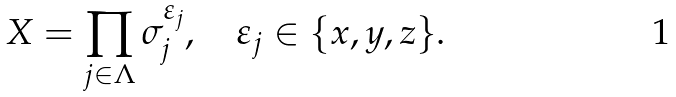<formula> <loc_0><loc_0><loc_500><loc_500>X = \prod _ { j \in \Lambda } \sigma ^ { \varepsilon _ { j } } _ { j } , \quad \varepsilon _ { j } \in \{ x , y , z \} .</formula> 